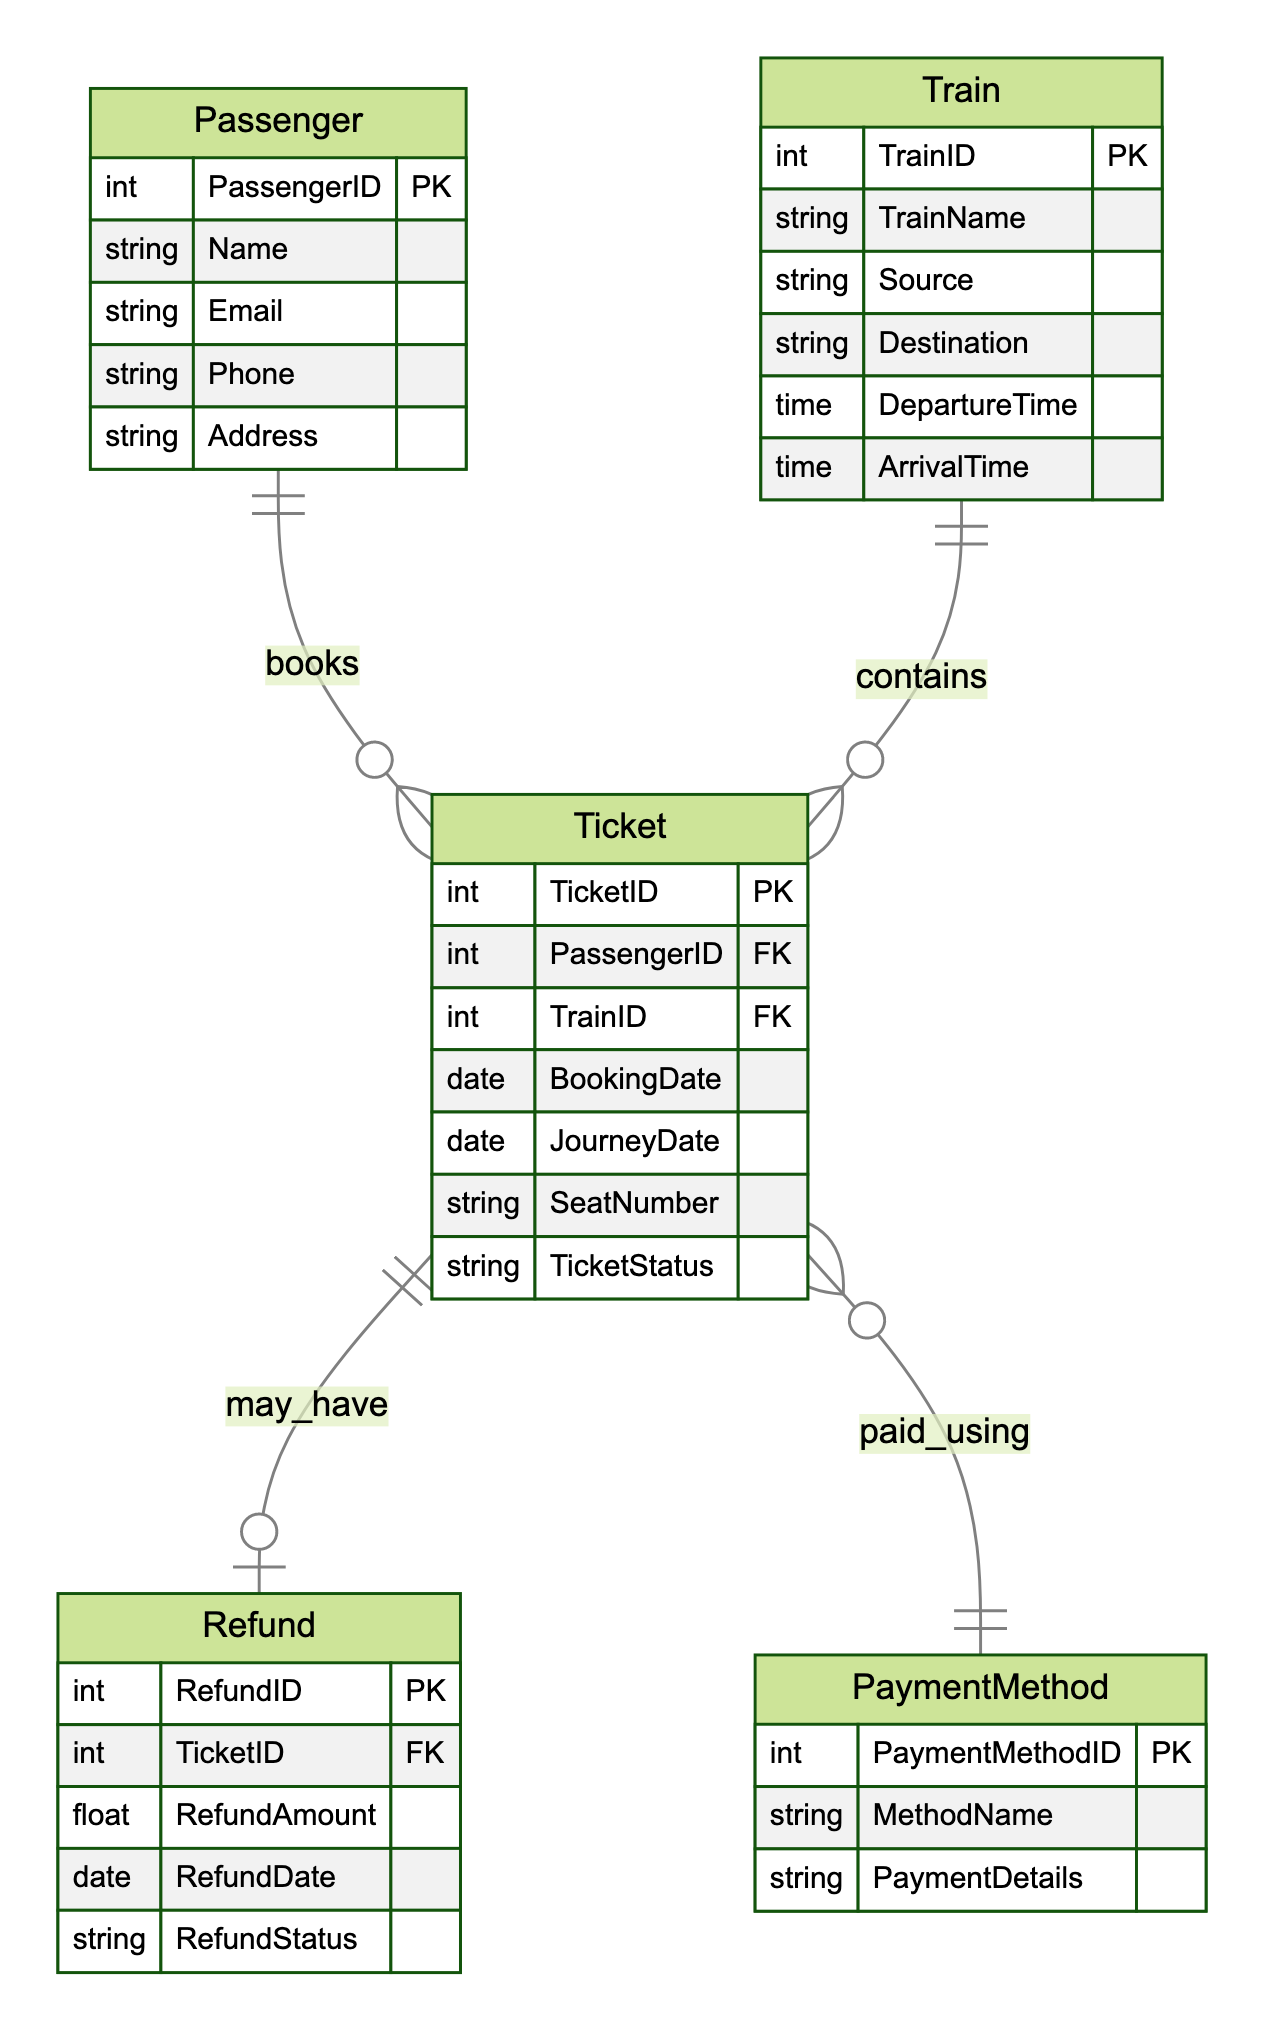What is the primary key of the Ticket entity? The primary key of the Ticket entity is TicketID, as indicated in the diagram where PK is noted for this attribute.
Answer: TicketID How many entities are present in the diagram? The diagram shows a total of five entities: Passenger, Ticket, Train, PaymentMethod, and Refund. This is counted by looking at the list of entities detailed in the diagram.
Answer: Five What type of relationship exists between Passenger and Ticket? The relationship between Passenger and Ticket is a one-to-many relationship, as denoted by the notation "1-to-Many" in the relationship descriptions. This indicates that one Passenger can book multiple Tickets.
Answer: One-to-Many Which entity may have a Refund? The entity that may have a Refund is Ticket, as described by the relationship "may_have" which connects Ticket to Refund and indicates that each Ticket can be associated with one Refund.
Answer: Ticket How many attributes are associated with the PaymentMethod entity? The PaymentMethod entity contains three attributes: PaymentMethodID, MethodName, and PaymentDetails. This is verified by checking the list of attributes under the PaymentMethod entity in the diagram.
Answer: Three If a Ticket is canceled, which entity would potentially be linked for a refund? A canceled Ticket would potentially be linked to the Refund entity, as indicated by the "may_have" relationship connecting Ticket to Refund, signifying that a refund may be processed for a canceled Ticket.
Answer: Refund What is the relationship type between Ticket and PaymentMethod? The relationship type between Ticket and PaymentMethod is many-to-one, as indicated in the diagram where the description states "Many-to-1", meaning multiple Tickets can be paid using the same PaymentMethod.
Answer: Many-to-One What is the attribute that indicates the Train's destination? The attribute indicating the Train's destination is Destination, characterized in the Train entity's attributes list. This attribute specifies where the train is headed.
Answer: Destination Which entity is linked to Refund through Ticket? The entity linked to Refund through Ticket is Ticket itself, as per the "may_have" relationship that specifies each Ticket can have one associated Refund.
Answer: Ticket 